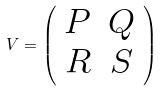<formula> <loc_0><loc_0><loc_500><loc_500>V = \left ( \begin{array} { c c } P & Q \\ R & S \end{array} \right )</formula> 